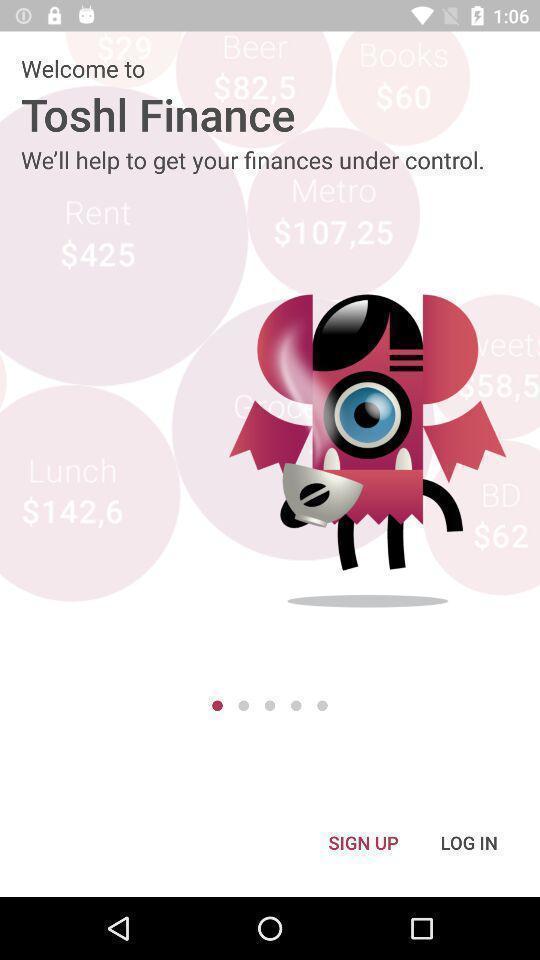Give me a summary of this screen capture. Welcome page to log-in for finance app. 